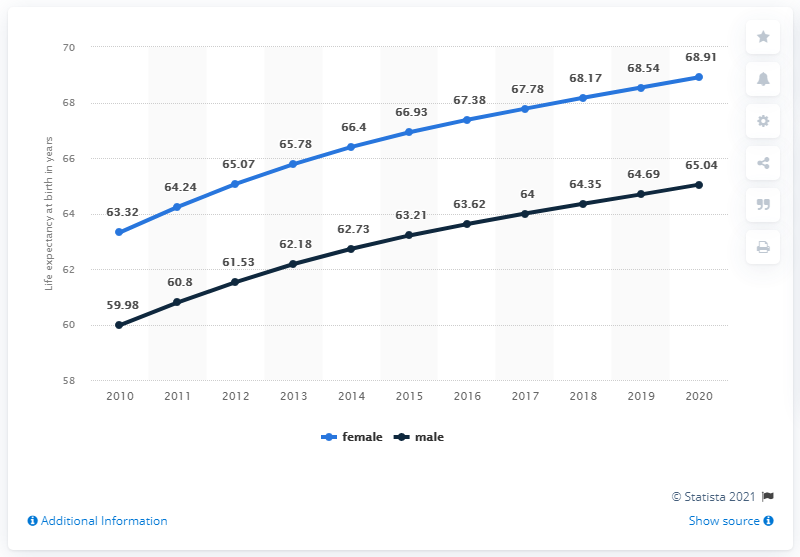Specify some key components in this picture. For approximately 8 years, the average lifespan of males has exceeded 62 years. According to recent data, the peak in female life expectancy at birth was reached in 2020. 